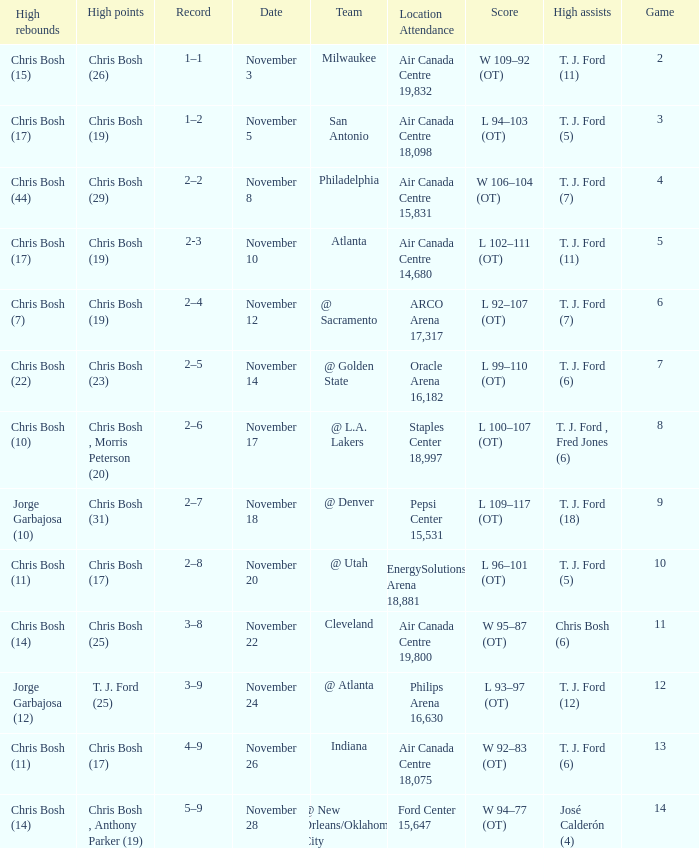Who had high assists when they played against San Antonio? T. J. Ford (5). 